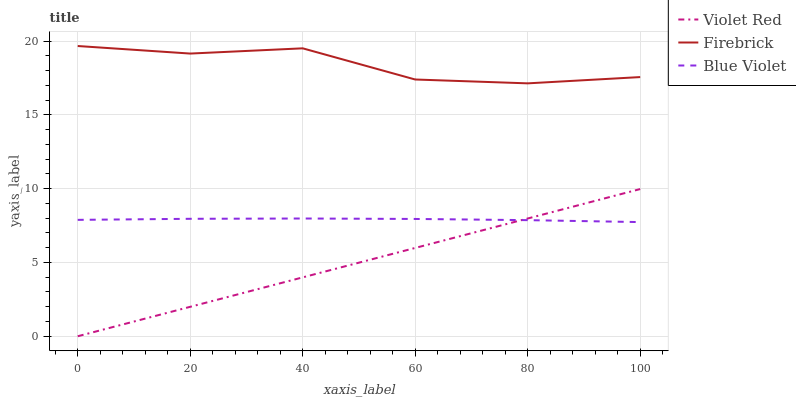Does Violet Red have the minimum area under the curve?
Answer yes or no. Yes. Does Firebrick have the maximum area under the curve?
Answer yes or no. Yes. Does Blue Violet have the minimum area under the curve?
Answer yes or no. No. Does Blue Violet have the maximum area under the curve?
Answer yes or no. No. Is Violet Red the smoothest?
Answer yes or no. Yes. Is Firebrick the roughest?
Answer yes or no. Yes. Is Blue Violet the smoothest?
Answer yes or no. No. Is Blue Violet the roughest?
Answer yes or no. No. Does Violet Red have the lowest value?
Answer yes or no. Yes. Does Blue Violet have the lowest value?
Answer yes or no. No. Does Firebrick have the highest value?
Answer yes or no. Yes. Does Blue Violet have the highest value?
Answer yes or no. No. Is Violet Red less than Firebrick?
Answer yes or no. Yes. Is Firebrick greater than Violet Red?
Answer yes or no. Yes. Does Blue Violet intersect Violet Red?
Answer yes or no. Yes. Is Blue Violet less than Violet Red?
Answer yes or no. No. Is Blue Violet greater than Violet Red?
Answer yes or no. No. Does Violet Red intersect Firebrick?
Answer yes or no. No. 